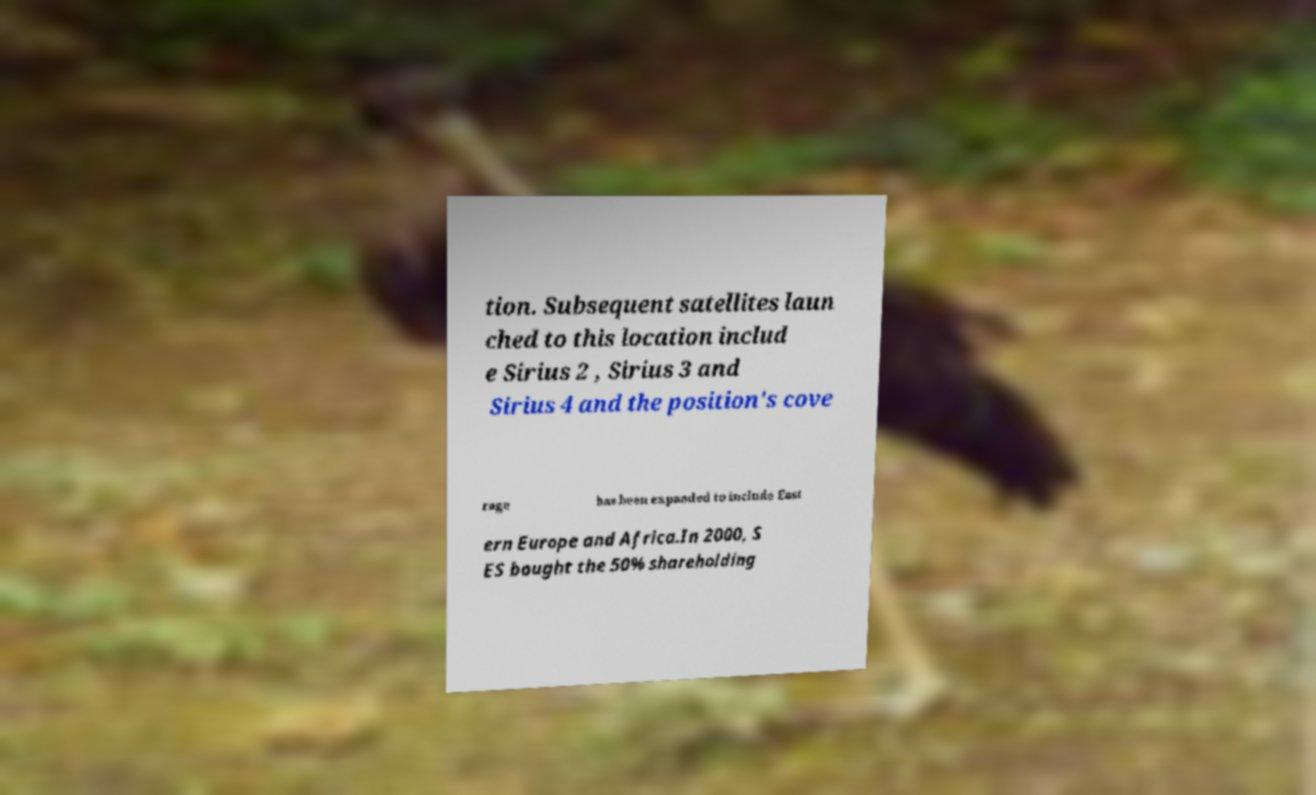Could you extract and type out the text from this image? tion. Subsequent satellites laun ched to this location includ e Sirius 2 , Sirius 3 and Sirius 4 and the position's cove rage has been expanded to include East ern Europe and Africa.In 2000, S ES bought the 50% shareholding 